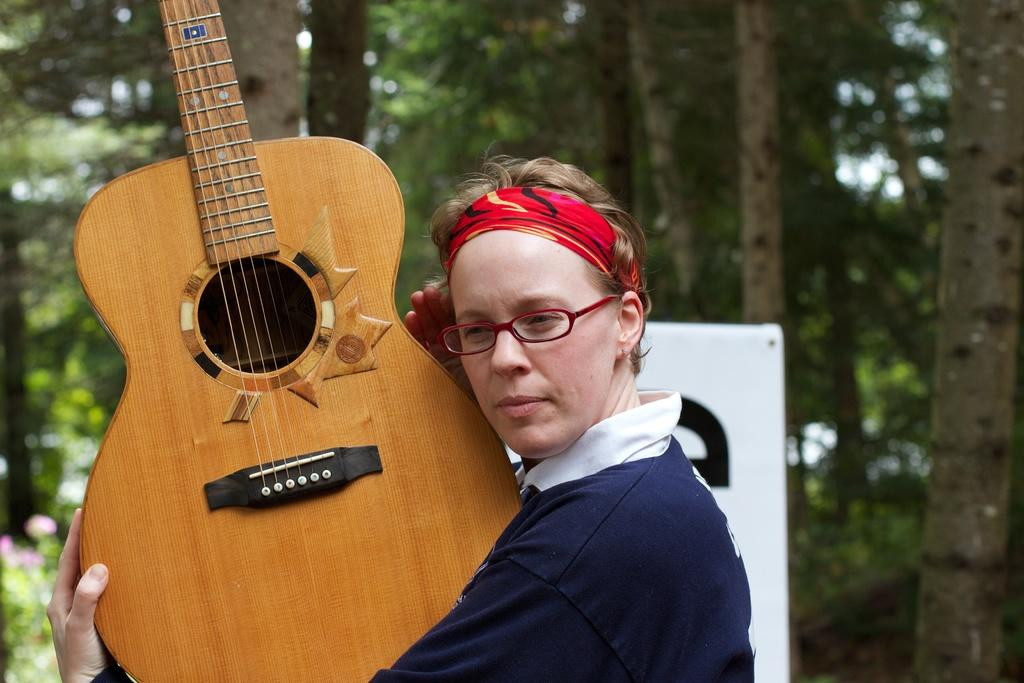What is the person in the image holding? The person is holding a guitar in the image. What can be seen in the background of the image? There are trees in the background of the image. What type of crack is visible on the guitar in the image? There is no crack visible on the guitar in the image. What time of day is it in the image? The time of day is not mentioned or depicted in the image, so it cannot be determined. 